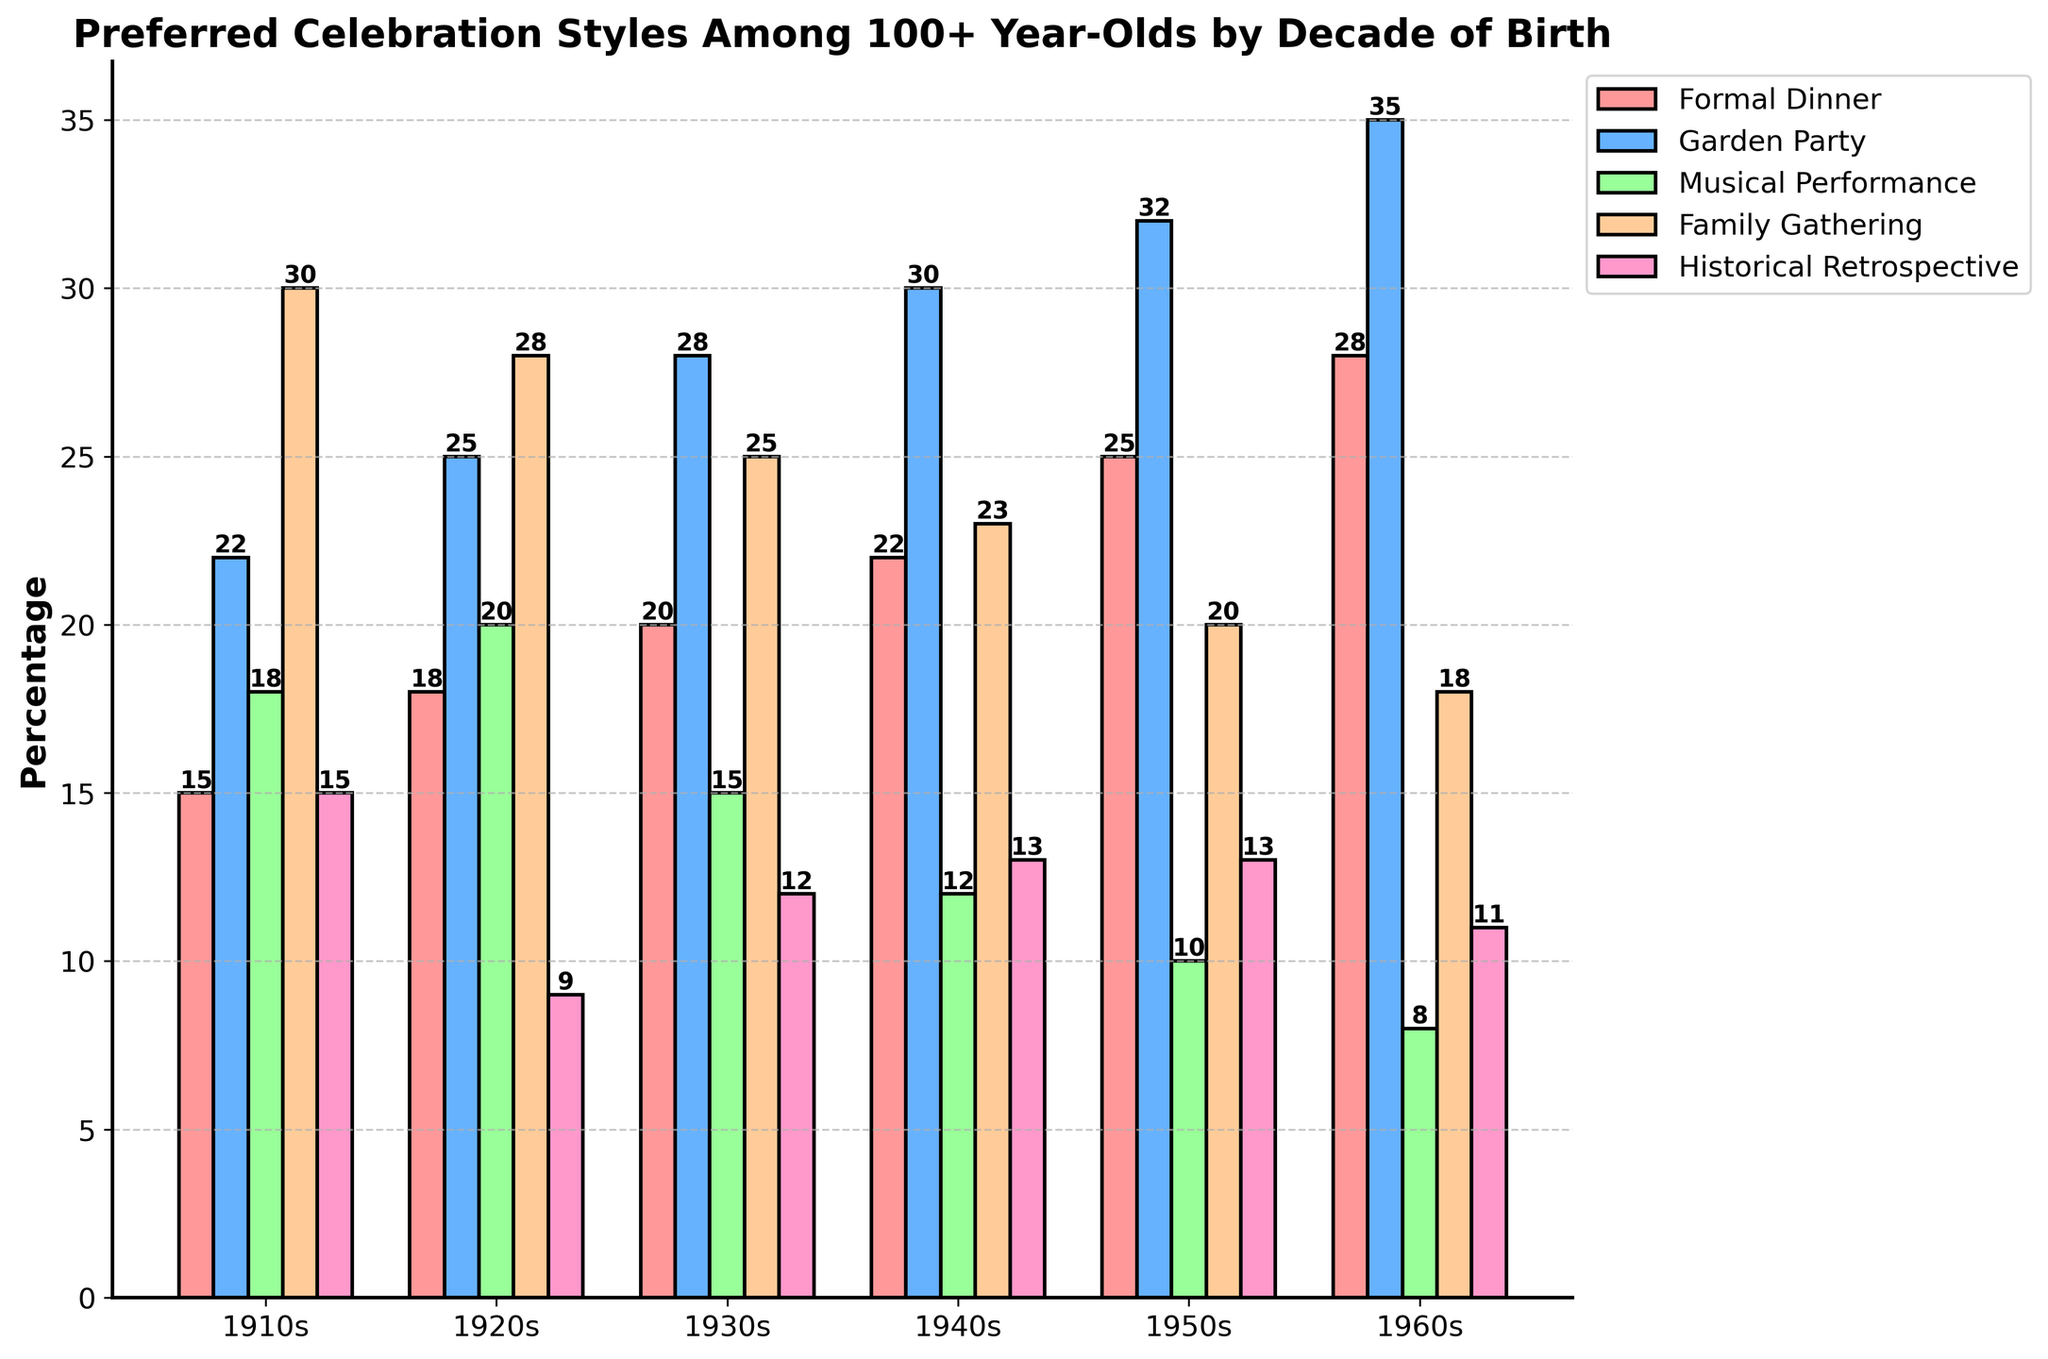Which celebration style was the most preferred by people born in the 1910s? To identify the most preferred style, look at the bar heights for each category for the 1910s decade. The highest bar corresponds to "Family Gathering" with a value of 30.
Answer: Family Gathering Is there any celebration style that shows a consistent increase in preference from the 1910s to the 1960s? Check the values for each celebration style from the 1910s to the 1960s. The "Formal Dinner" and "Garden Party" both show consistent increases in preference across these decades.
Answer: Formal Dinner and Garden Party What is the difference in preference for "Musical Performance" between the 1920s and 1960s? Subtract the value for Musical Performance in the 1960s (8) from the value in the 1920s (20). The calculation is 20 - 8 = 12.
Answer: 12 Among people born in the 1940s, which is more preferred: "Historical Retrospective" or "Musical Performance"? Compare the bar heights for "Historical Retrospective" and "Musical Performance" in the 1940s. "Historical Retrospective" has a value of 13, while "Musical Performance" has a value of 12. Therefore, "Historical Retrospective" is more preferred.
Answer: Historical Retrospective What is the average preference percentage for "Garden Party" across all decades? Sum the preference percentages for Garden Party across all decades: 22 + 25 + 28 + 30 + 32 + 35 = 172. Then, divide by the number of decades (6). 172/6 = 28.67.
Answer: 28.67 Which decade shows the highest preference for "Family Gathering"? Check the values for "Family Gathering" in each decade. The 1910s have the highest value at 30.
Answer: 1910s What can you infer about the trend for "Historical Retrospective" from 1910s to 1960s? Look at the values for "Historical Retrospective" from the 1910s (15), 1920s (9), 1930s (12), 1940s (13), 1950s (13), and 1960s (11). It shows no clear increasing or decreasing trend, remaining relatively stable.
Answer: Relatively stable Which two decades have the smallest difference in preference for "Formal Dinner"? Calculate the differences between the values of "Formal Dinner" for each pair of decades. The smallest difference is between the 1910s (15) and 1920s (18), with a difference of 3.
Answer: 1910s and 1920s 